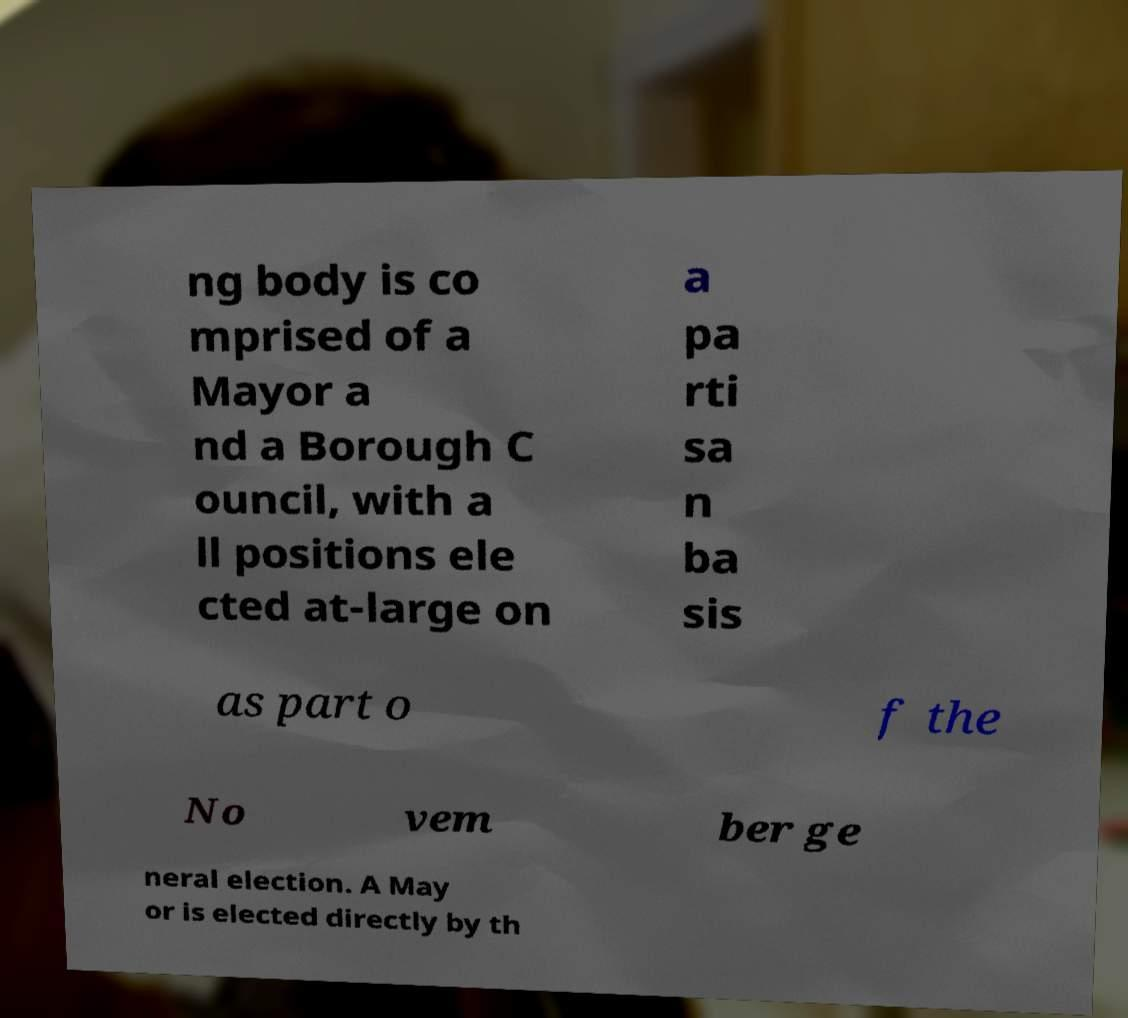Could you extract and type out the text from this image? ng body is co mprised of a Mayor a nd a Borough C ouncil, with a ll positions ele cted at-large on a pa rti sa n ba sis as part o f the No vem ber ge neral election. A May or is elected directly by th 